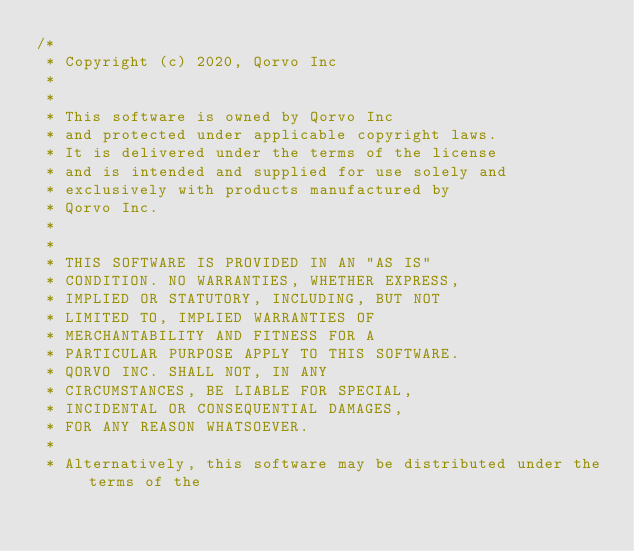Convert code to text. <code><loc_0><loc_0><loc_500><loc_500><_C_>/*
 * Copyright (c) 2020, Qorvo Inc
 *
 *
 * This software is owned by Qorvo Inc
 * and protected under applicable copyright laws.
 * It is delivered under the terms of the license
 * and is intended and supplied for use solely and
 * exclusively with products manufactured by
 * Qorvo Inc.
 *
 *
 * THIS SOFTWARE IS PROVIDED IN AN "AS IS"
 * CONDITION. NO WARRANTIES, WHETHER EXPRESS,
 * IMPLIED OR STATUTORY, INCLUDING, BUT NOT
 * LIMITED TO, IMPLIED WARRANTIES OF
 * MERCHANTABILITY AND FITNESS FOR A
 * PARTICULAR PURPOSE APPLY TO THIS SOFTWARE.
 * QORVO INC. SHALL NOT, IN ANY
 * CIRCUMSTANCES, BE LIABLE FOR SPECIAL,
 * INCIDENTAL OR CONSEQUENTIAL DAMAGES,
 * FOR ANY REASON WHATSOEVER.
 *
 * Alternatively, this software may be distributed under the terms of the</code> 